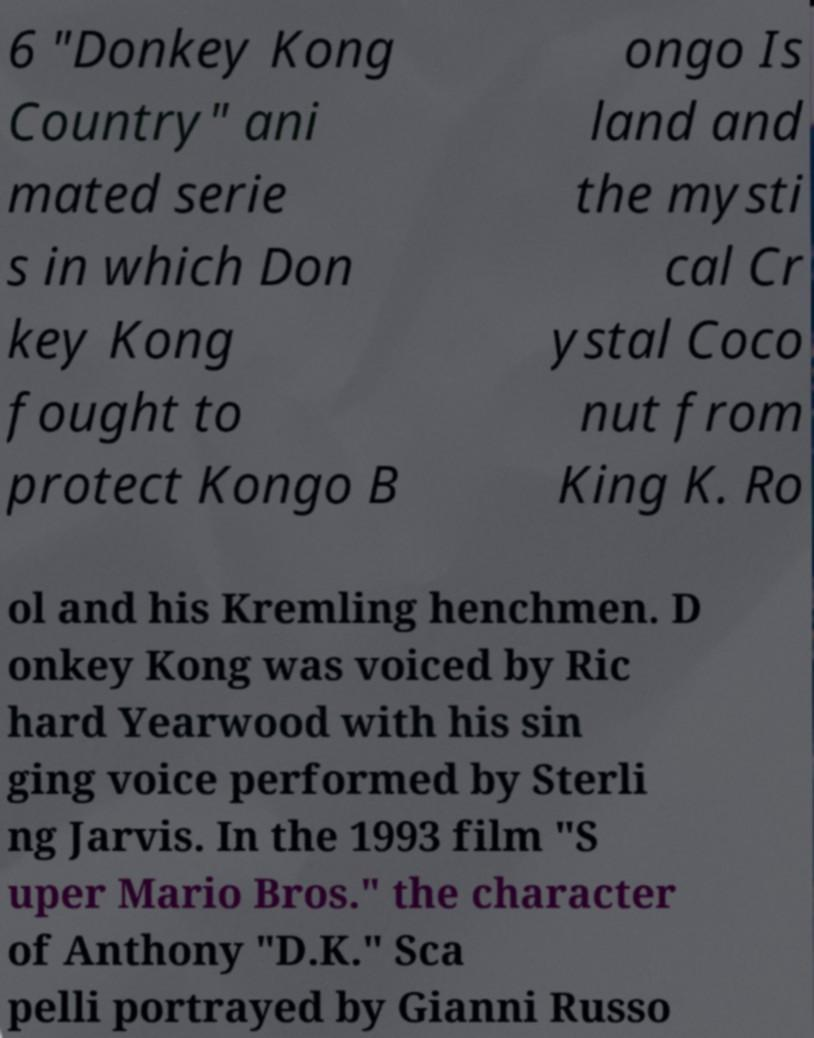For documentation purposes, I need the text within this image transcribed. Could you provide that? 6 "Donkey Kong Country" ani mated serie s in which Don key Kong fought to protect Kongo B ongo Is land and the mysti cal Cr ystal Coco nut from King K. Ro ol and his Kremling henchmen. D onkey Kong was voiced by Ric hard Yearwood with his sin ging voice performed by Sterli ng Jarvis. In the 1993 film "S uper Mario Bros." the character of Anthony "D.K." Sca pelli portrayed by Gianni Russo 